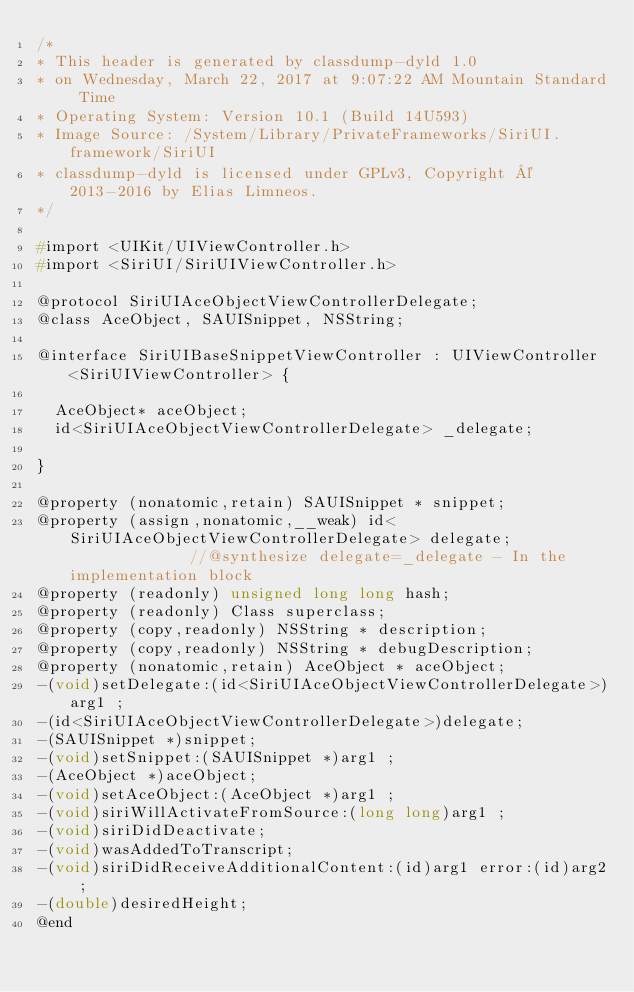Convert code to text. <code><loc_0><loc_0><loc_500><loc_500><_C_>/*
* This header is generated by classdump-dyld 1.0
* on Wednesday, March 22, 2017 at 9:07:22 AM Mountain Standard Time
* Operating System: Version 10.1 (Build 14U593)
* Image Source: /System/Library/PrivateFrameworks/SiriUI.framework/SiriUI
* classdump-dyld is licensed under GPLv3, Copyright © 2013-2016 by Elias Limneos.
*/

#import <UIKit/UIViewController.h>
#import <SiriUI/SiriUIViewController.h>

@protocol SiriUIAceObjectViewControllerDelegate;
@class AceObject, SAUISnippet, NSString;

@interface SiriUIBaseSnippetViewController : UIViewController <SiriUIViewController> {

	AceObject* aceObject;
	id<SiriUIAceObjectViewControllerDelegate> _delegate;

}

@property (nonatomic,retain) SAUISnippet * snippet; 
@property (assign,nonatomic,__weak) id<SiriUIAceObjectViewControllerDelegate> delegate;              //@synthesize delegate=_delegate - In the implementation block
@property (readonly) unsigned long long hash; 
@property (readonly) Class superclass; 
@property (copy,readonly) NSString * description; 
@property (copy,readonly) NSString * debugDescription; 
@property (nonatomic,retain) AceObject * aceObject; 
-(void)setDelegate:(id<SiriUIAceObjectViewControllerDelegate>)arg1 ;
-(id<SiriUIAceObjectViewControllerDelegate>)delegate;
-(SAUISnippet *)snippet;
-(void)setSnippet:(SAUISnippet *)arg1 ;
-(AceObject *)aceObject;
-(void)setAceObject:(AceObject *)arg1 ;
-(void)siriWillActivateFromSource:(long long)arg1 ;
-(void)siriDidDeactivate;
-(void)wasAddedToTranscript;
-(void)siriDidReceiveAdditionalContent:(id)arg1 error:(id)arg2 ;
-(double)desiredHeight;
@end

</code> 